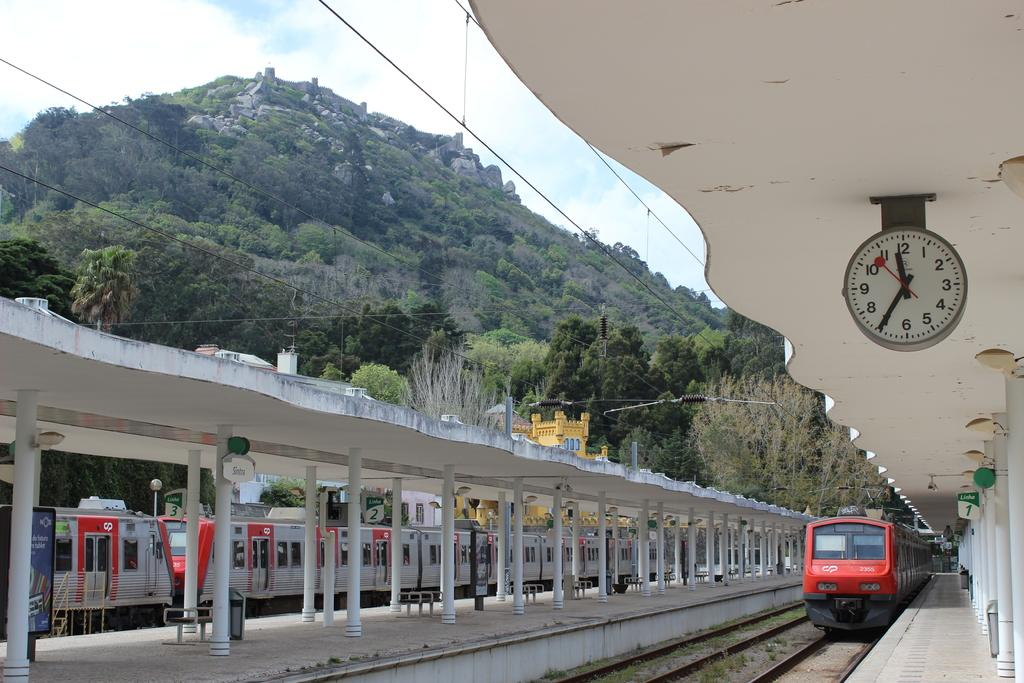Provide a one-sentence caption for the provided image. A clock tells the time of 11:35 am at a train station. 